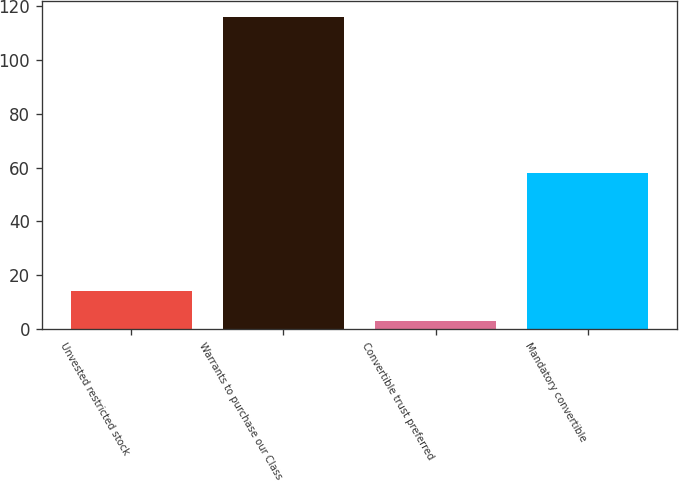Convert chart to OTSL. <chart><loc_0><loc_0><loc_500><loc_500><bar_chart><fcel>Unvested restricted stock<fcel>Warrants to purchase our Class<fcel>Convertible trust preferred<fcel>Mandatory convertible<nl><fcel>14.3<fcel>116<fcel>3<fcel>58<nl></chart> 